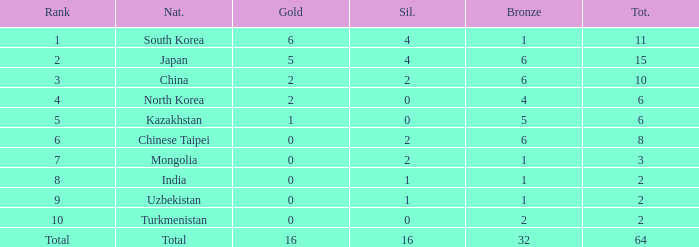What's the biggest Bronze that has less than 0 Silvers? None. 